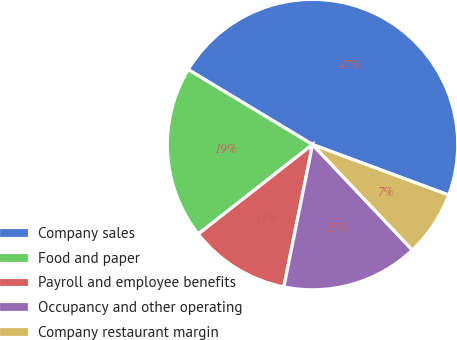<chart> <loc_0><loc_0><loc_500><loc_500><pie_chart><fcel>Company sales<fcel>Food and paper<fcel>Payroll and employee benefits<fcel>Occupancy and other operating<fcel>Company restaurant margin<nl><fcel>47.01%<fcel>19.21%<fcel>11.26%<fcel>15.23%<fcel>7.29%<nl></chart> 